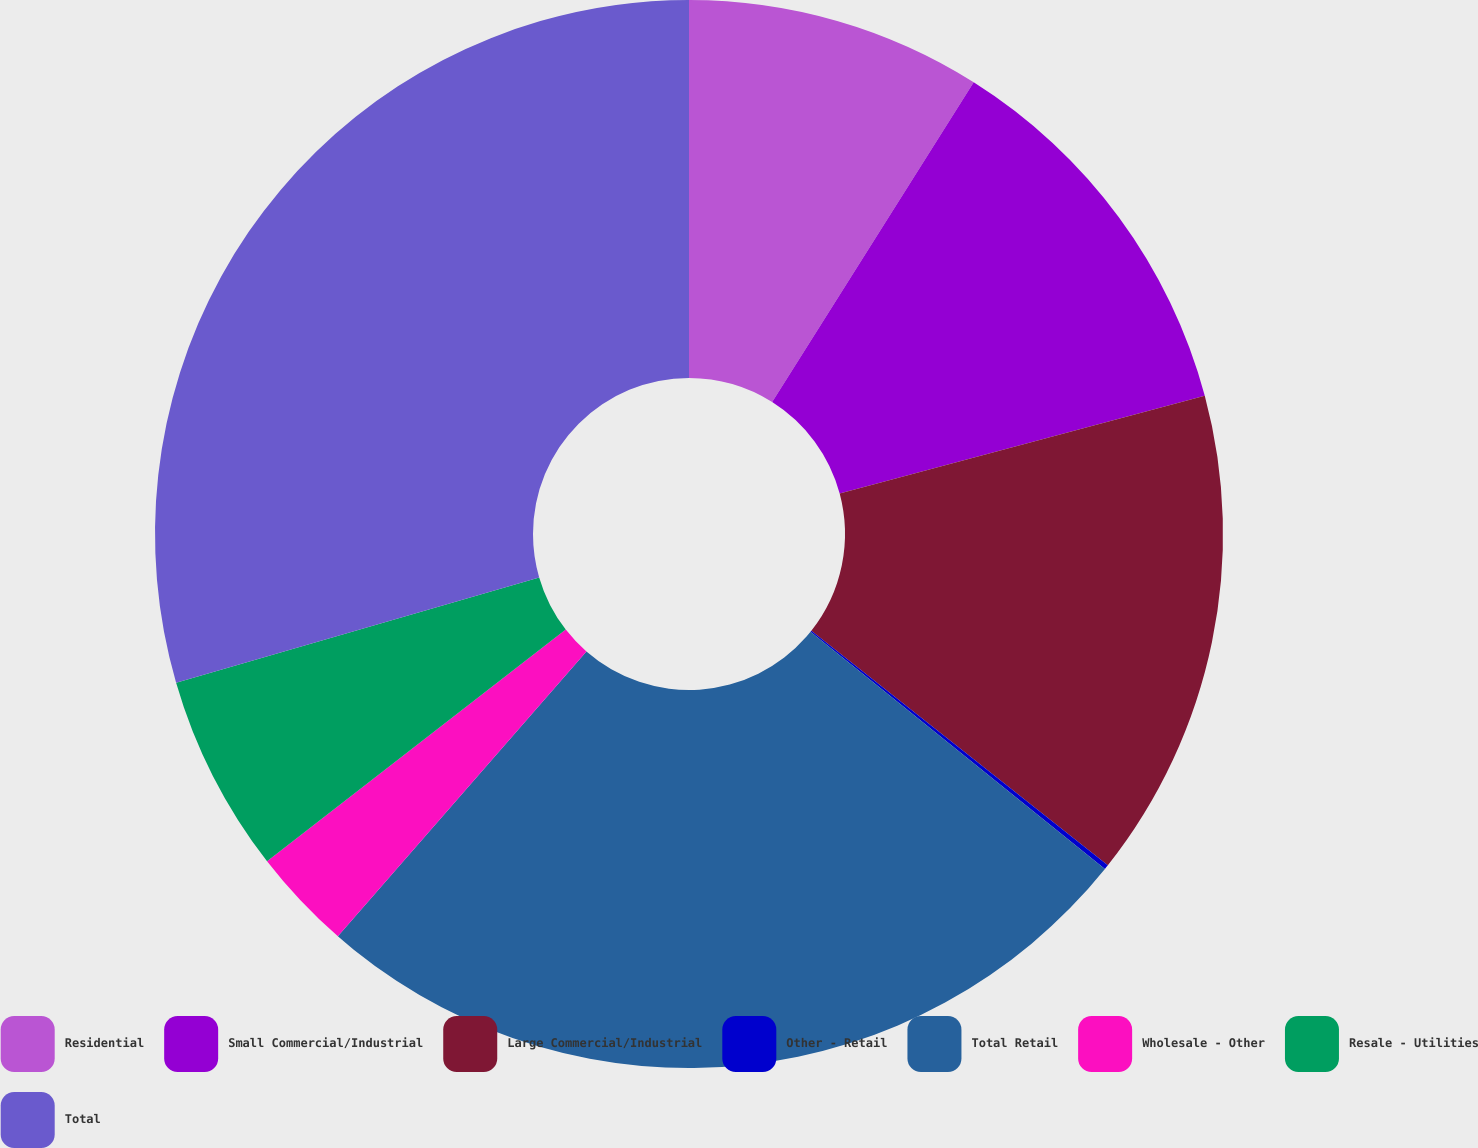Convert chart. <chart><loc_0><loc_0><loc_500><loc_500><pie_chart><fcel>Residential<fcel>Small Commercial/Industrial<fcel>Large Commercial/Industrial<fcel>Other - Retail<fcel>Total Retail<fcel>Wholesale - Other<fcel>Resale - Utilities<fcel>Total<nl><fcel>8.95%<fcel>11.88%<fcel>14.82%<fcel>0.14%<fcel>25.63%<fcel>3.08%<fcel>6.01%<fcel>29.49%<nl></chart> 